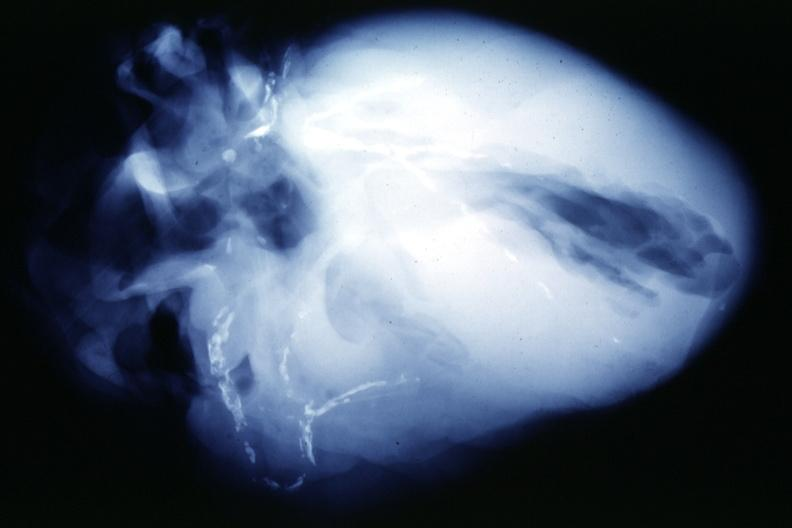what is present?
Answer the question using a single word or phrase. Coronary artery 